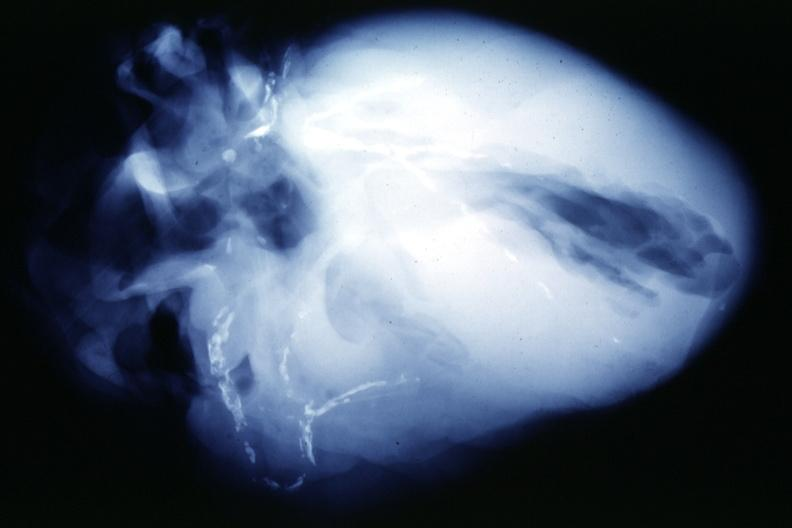what is present?
Answer the question using a single word or phrase. Coronary artery 